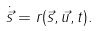Convert formula to latex. <formula><loc_0><loc_0><loc_500><loc_500>\dot { \vec { s } } = r ( \vec { s } , \vec { u } , t ) .</formula> 